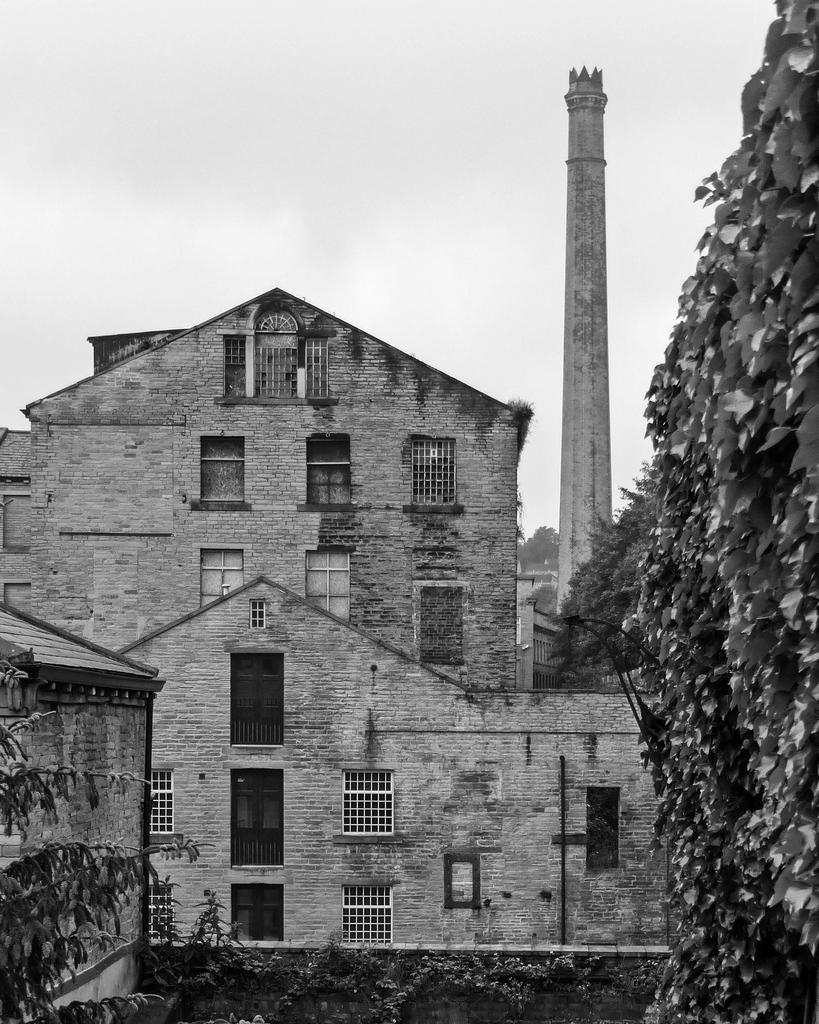What type of structure is present in the image? There is a building in the image. What part of the building is visible? There is a window in the building. What type of vegetation can be seen in the image? There are plants and trees in the image. What type of barrier is present in the image? There is a fence in the image. What other architectural feature is present in the image? There is a tower in the image. What is visible in the background of the image? The sky is visible in the image. What type of art is being displayed in the building's window? There is no art visible in the building's window in the image. What societal issues are being discussed in the image? The image does not depict any societal issues or discussions. 